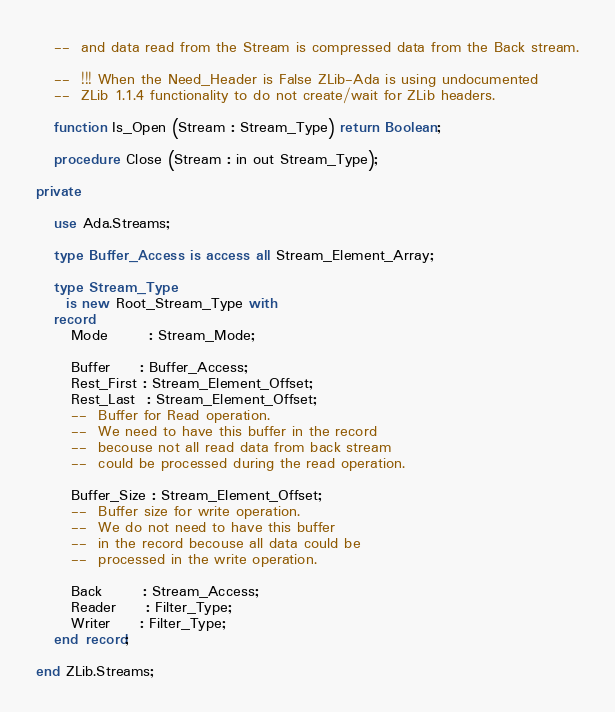Convert code to text. <code><loc_0><loc_0><loc_500><loc_500><_Ada_>   --  and data read from the Stream is compressed data from the Back stream.

   --  !!! When the Need_Header is False ZLib-Ada is using undocumented
   --  ZLib 1.1.4 functionality to do not create/wait for ZLib headers.

   function Is_Open (Stream : Stream_Type) return Boolean;

   procedure Close (Stream : in out Stream_Type);

private

   use Ada.Streams;

   type Buffer_Access is access all Stream_Element_Array;

   type Stream_Type
     is new Root_Stream_Type with
   record
      Mode       : Stream_Mode;

      Buffer     : Buffer_Access;
      Rest_First : Stream_Element_Offset;
      Rest_Last  : Stream_Element_Offset;
      --  Buffer for Read operation.
      --  We need to have this buffer in the record
      --  becouse not all read data from back stream
      --  could be processed during the read operation.

      Buffer_Size : Stream_Element_Offset;
      --  Buffer size for write operation.
      --  We do not need to have this buffer
      --  in the record becouse all data could be
      --  processed in the write operation.

      Back       : Stream_Access;
      Reader     : Filter_Type;
      Writer     : Filter_Type;
   end record;

end ZLib.Streams;
</code> 